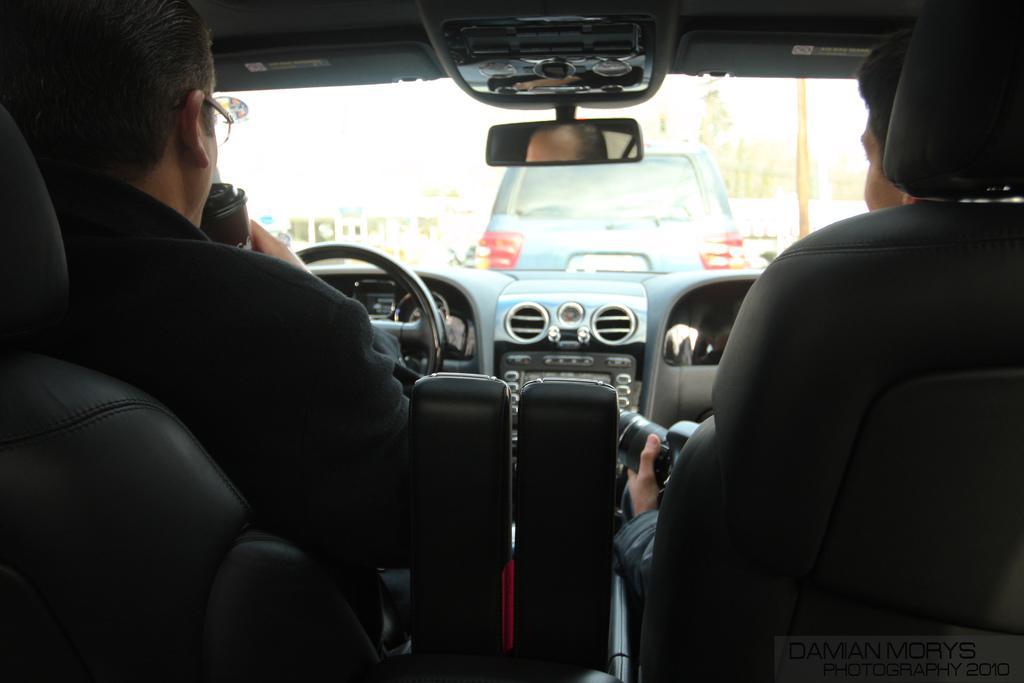Could you give a brief overview of what you see in this image? This is an inside view of a car. Here I can see two persons are sitting. The person who is on the right side is holding a camera in the hands. They are facing to the backside. In the background there is a glass through which we can see the outside view. In the outside there is another car. 